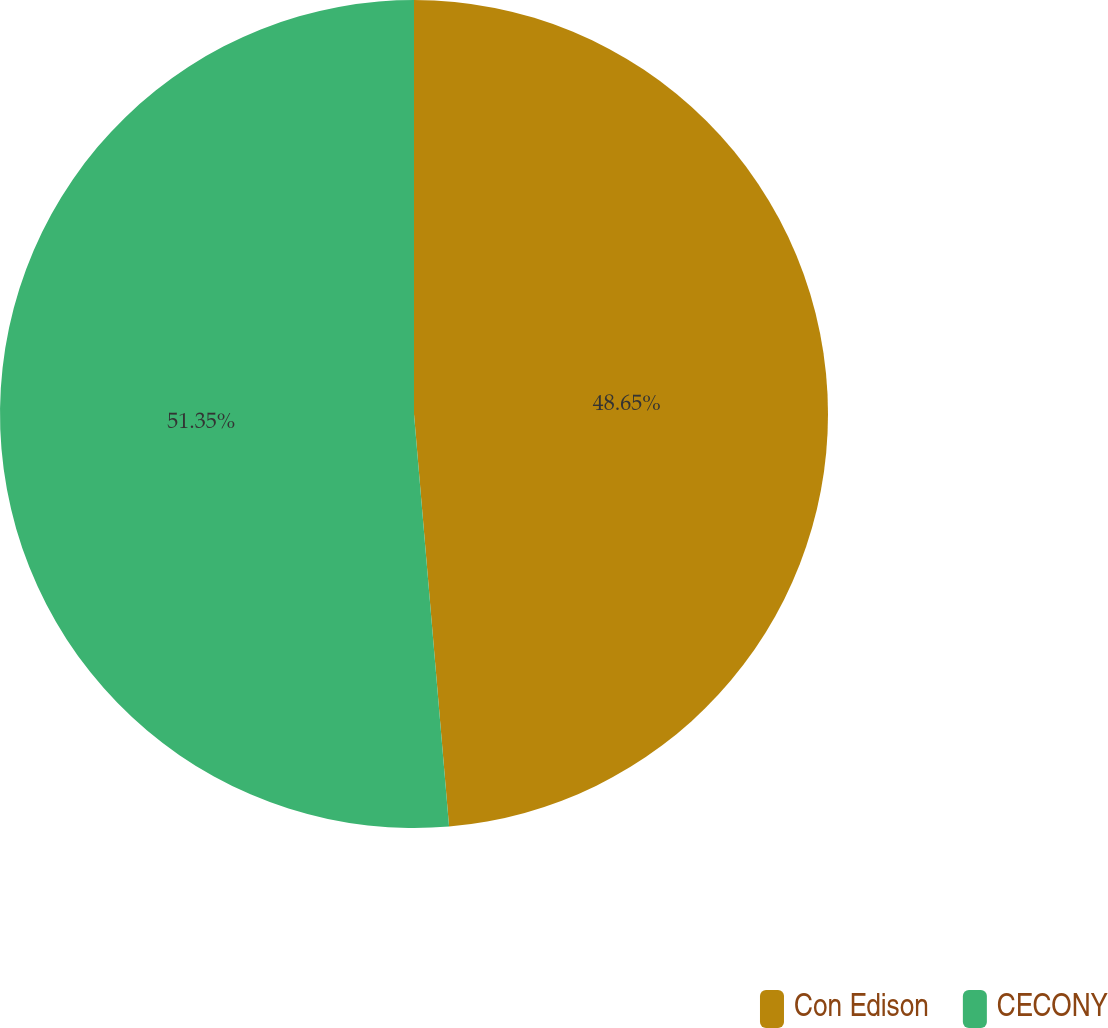<chart> <loc_0><loc_0><loc_500><loc_500><pie_chart><fcel>Con Edison<fcel>CECONY<nl><fcel>48.65%<fcel>51.35%<nl></chart> 